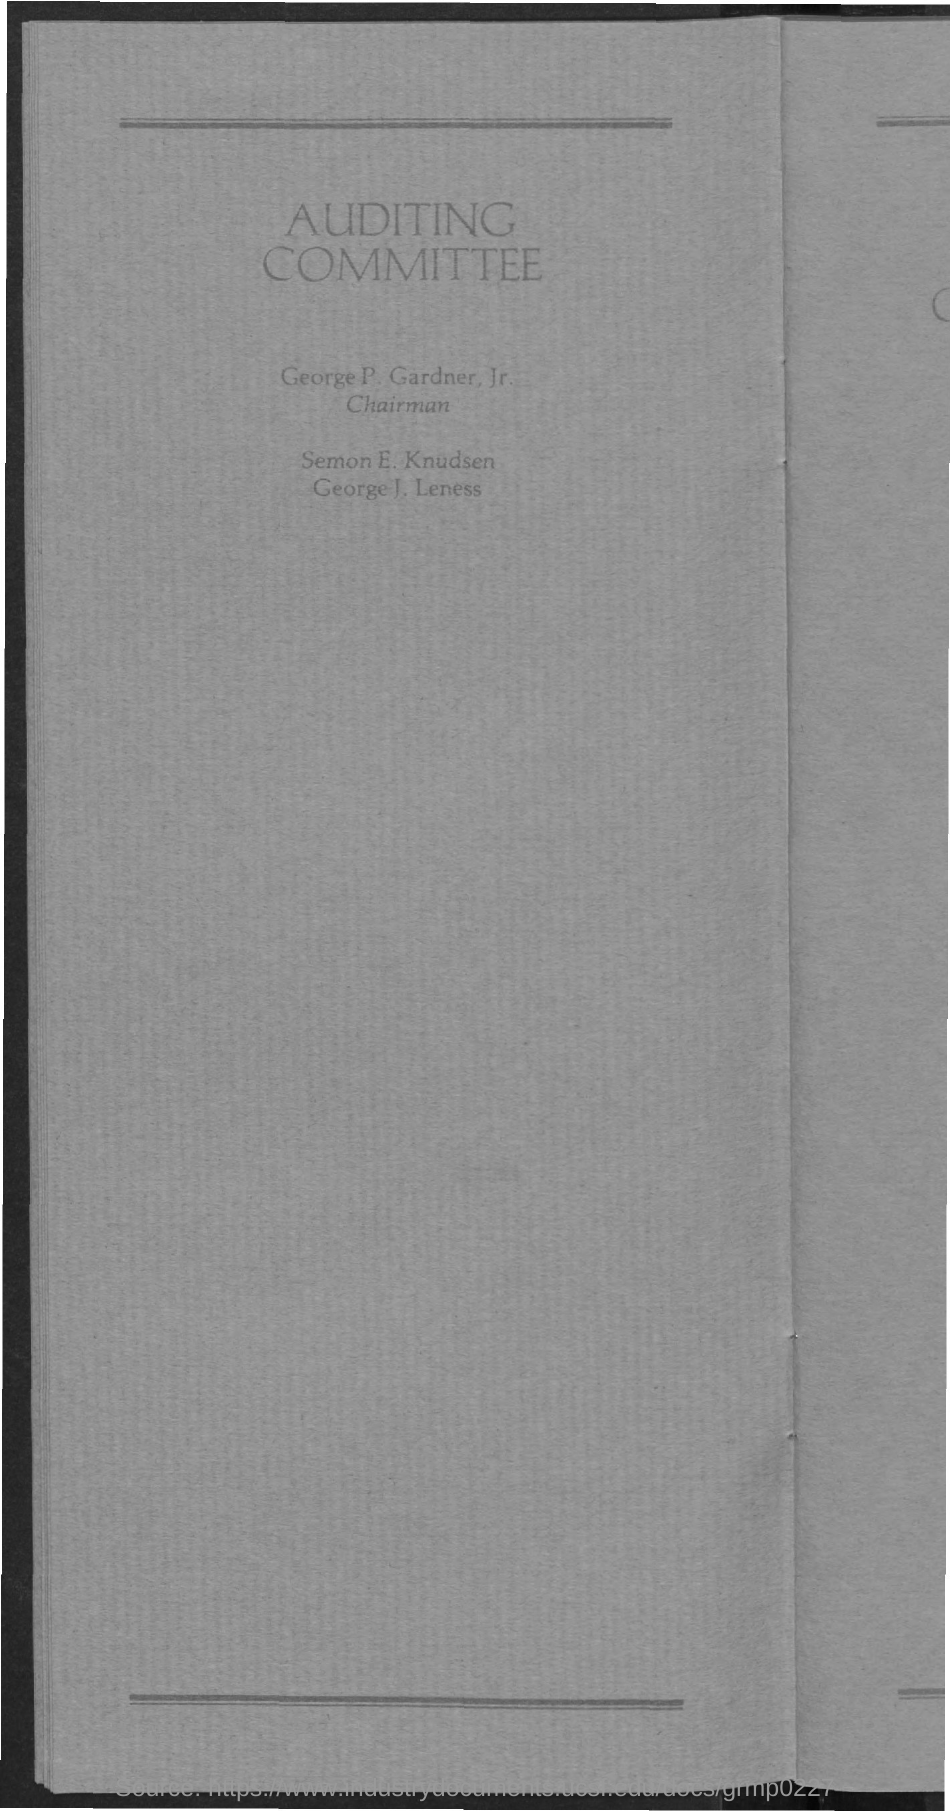Specify some key components in this picture. The title of the document is 'Auditing Committee.' 